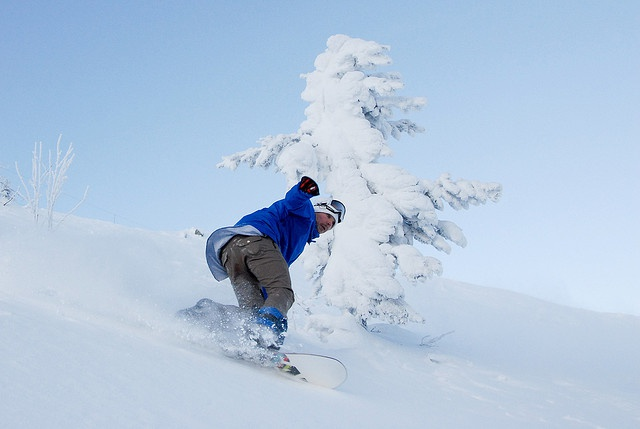Describe the objects in this image and their specific colors. I can see people in lightblue, gray, navy, darkgray, and black tones and snowboard in lightblue, lightgray, and darkgray tones in this image. 